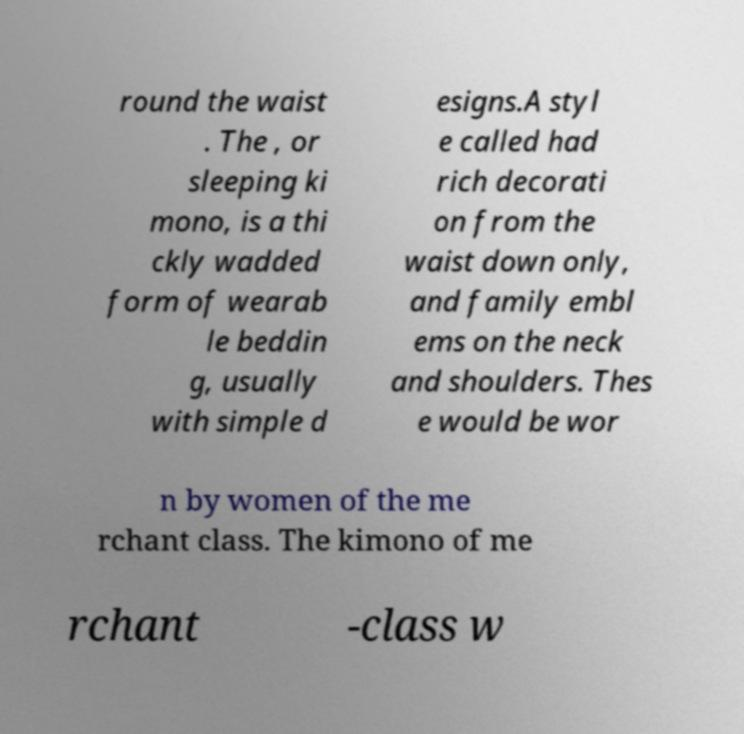Can you read and provide the text displayed in the image?This photo seems to have some interesting text. Can you extract and type it out for me? round the waist . The , or sleeping ki mono, is a thi ckly wadded form of wearab le beddin g, usually with simple d esigns.A styl e called had rich decorati on from the waist down only, and family embl ems on the neck and shoulders. Thes e would be wor n by women of the me rchant class. The kimono of me rchant -class w 